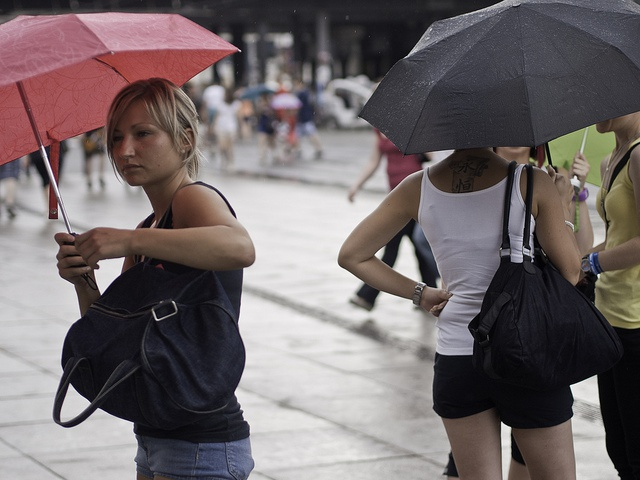Describe the objects in this image and their specific colors. I can see people in black and gray tones, umbrella in black and gray tones, people in black, gray, and maroon tones, handbag in black, lightgray, and gray tones, and umbrella in black, brown, lightpink, and salmon tones in this image. 